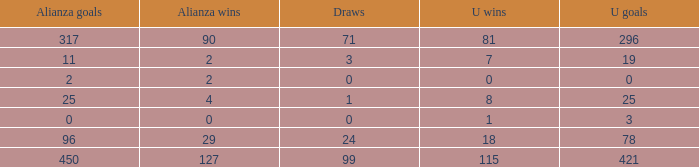What is the lowest U Wins, when Alianza Wins is greater than 0, when Alianza Goals is greater than 25, and when Draws is "99"? 115.0. 